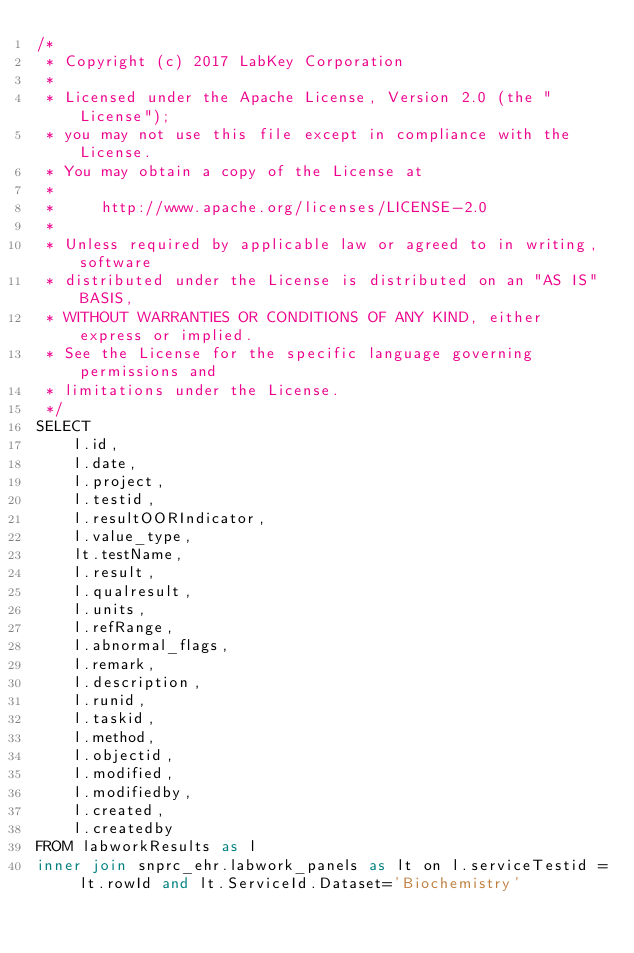Convert code to text. <code><loc_0><loc_0><loc_500><loc_500><_SQL_>/*
 * Copyright (c) 2017 LabKey Corporation
 *
 * Licensed under the Apache License, Version 2.0 (the "License");
 * you may not use this file except in compliance with the License.
 * You may obtain a copy of the License at
 *
 *     http://www.apache.org/licenses/LICENSE-2.0
 *
 * Unless required by applicable law or agreed to in writing, software
 * distributed under the License is distributed on an "AS IS" BASIS,
 * WITHOUT WARRANTIES OR CONDITIONS OF ANY KIND, either express or implied.
 * See the License for the specific language governing permissions and
 * limitations under the License.
 */
SELECT
	l.id,
	l.date,
	l.project,
	l.testid,
	l.resultOORIndicator,
	l.value_type,
	lt.testName,
	l.result,
	l.qualresult,
	l.units,
	l.refRange,
	l.abnormal_flags,
	l.remark,
	l.description,
	l.runid,
	l.taskid,
	l.method,
	l.objectid,
	l.modified,
	l.modifiedby,
	l.created,
	l.createdby
FROM labworkResults as l
inner join snprc_ehr.labwork_panels as lt on l.serviceTestid = lt.rowId and lt.ServiceId.Dataset='Biochemistry'</code> 